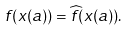Convert formula to latex. <formula><loc_0><loc_0><loc_500><loc_500>f ( x ( a ) ) = \widehat { f } ( x ( a ) ) .</formula> 